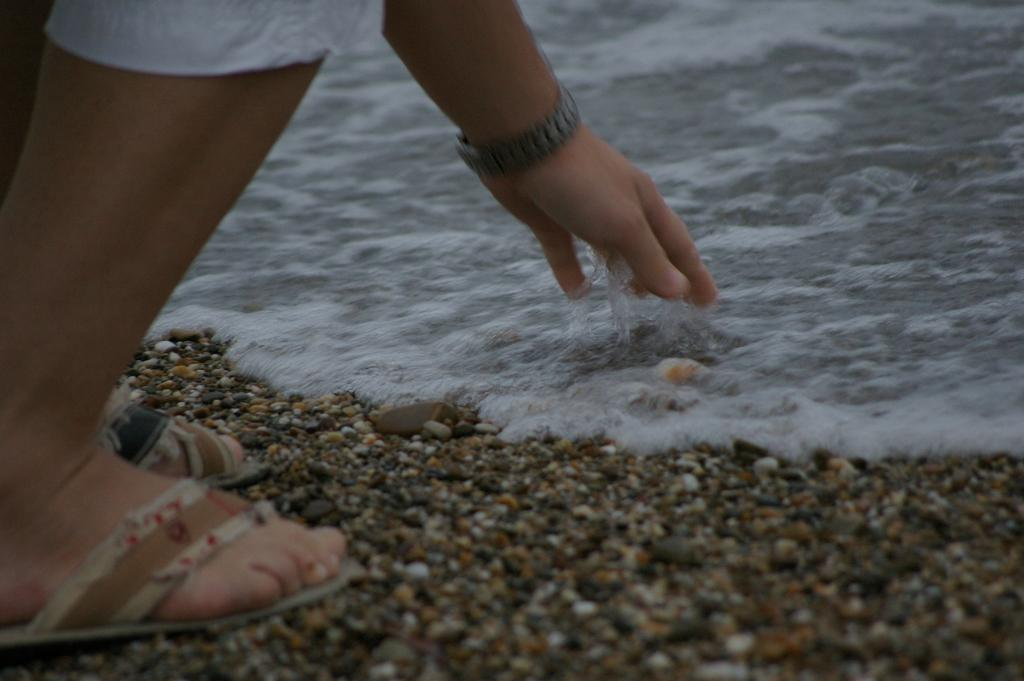What is the main subject of the image? There is a person standing in the image. What can be seen at the bottom of the image? There is water visible at the bottom of the image. What is present in the water? There are pebbles in the water. What class is the person attending in the image? There is no indication of a class or any educational setting in the image. 